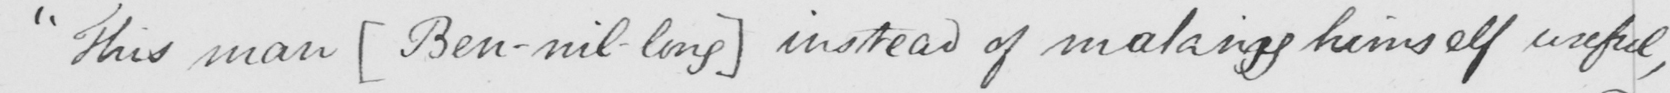What text is written in this handwritten line? " This man  [ Ben-nil-long ]  instead of making himself useful , 